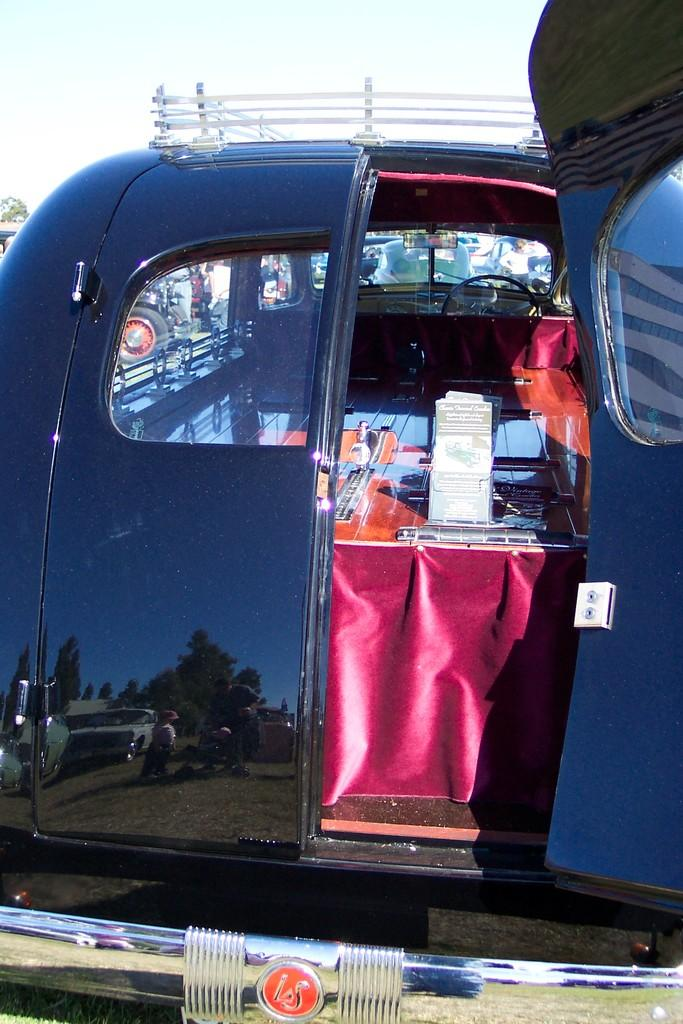What type of setting is depicted in the image? The image shows the interior of a motor vehicle. What can be seen in the background of the image? The sky is visible in the background of the image. What type of learning is taking place in the image? There is no indication of any learning taking place in the image; it shows the interior of a motor vehicle with the sky visible in the background. 